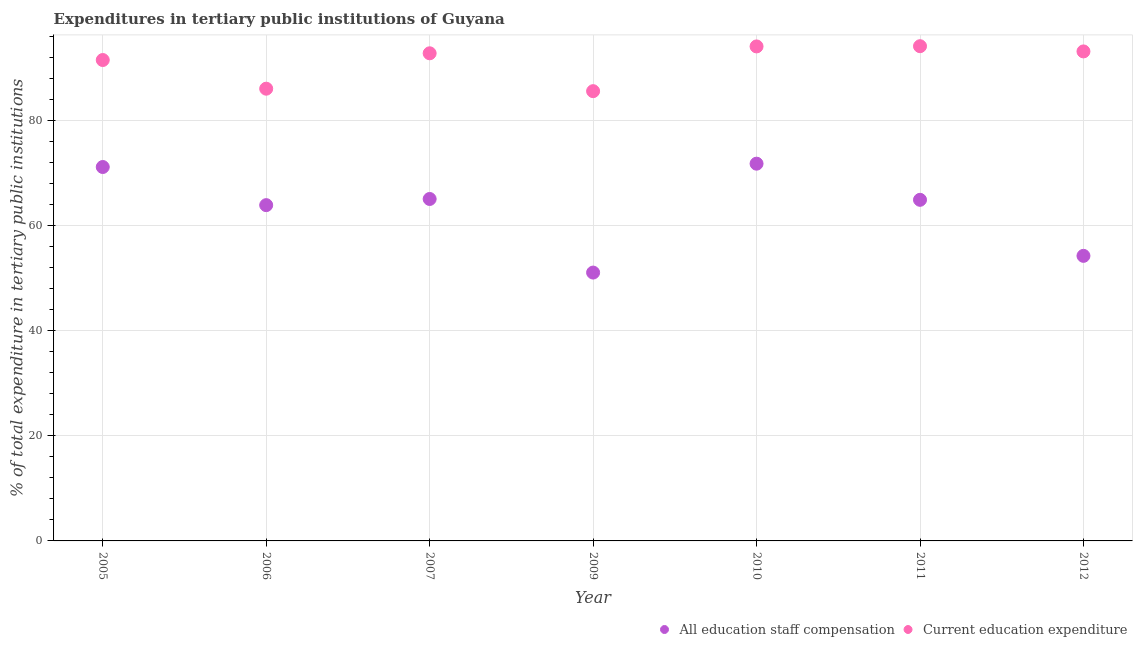How many different coloured dotlines are there?
Offer a very short reply. 2. Is the number of dotlines equal to the number of legend labels?
Provide a succinct answer. Yes. What is the expenditure in education in 2012?
Give a very brief answer. 93.13. Across all years, what is the maximum expenditure in education?
Provide a short and direct response. 94.13. Across all years, what is the minimum expenditure in education?
Provide a succinct answer. 85.57. In which year was the expenditure in staff compensation maximum?
Your response must be concise. 2010. In which year was the expenditure in staff compensation minimum?
Give a very brief answer. 2009. What is the total expenditure in staff compensation in the graph?
Provide a succinct answer. 442.04. What is the difference between the expenditure in staff compensation in 2009 and that in 2012?
Ensure brevity in your answer.  -3.18. What is the difference between the expenditure in staff compensation in 2010 and the expenditure in education in 2006?
Provide a succinct answer. -14.27. What is the average expenditure in staff compensation per year?
Offer a very short reply. 63.15. In the year 2011, what is the difference between the expenditure in staff compensation and expenditure in education?
Offer a terse response. -29.23. In how many years, is the expenditure in education greater than 68 %?
Keep it short and to the point. 7. What is the ratio of the expenditure in education in 2005 to that in 2012?
Your response must be concise. 0.98. Is the expenditure in education in 2007 less than that in 2011?
Your answer should be very brief. Yes. Is the difference between the expenditure in education in 2007 and 2012 greater than the difference between the expenditure in staff compensation in 2007 and 2012?
Provide a short and direct response. No. What is the difference between the highest and the second highest expenditure in staff compensation?
Your response must be concise. 0.63. What is the difference between the highest and the lowest expenditure in staff compensation?
Offer a very short reply. 20.72. In how many years, is the expenditure in education greater than the average expenditure in education taken over all years?
Provide a short and direct response. 5. Does the expenditure in staff compensation monotonically increase over the years?
Make the answer very short. No. Is the expenditure in staff compensation strictly less than the expenditure in education over the years?
Provide a short and direct response. Yes. Does the graph contain any zero values?
Keep it short and to the point. No. Does the graph contain grids?
Give a very brief answer. Yes. How many legend labels are there?
Your response must be concise. 2. What is the title of the graph?
Offer a terse response. Expenditures in tertiary public institutions of Guyana. Does "Enforce a contract" appear as one of the legend labels in the graph?
Your response must be concise. No. What is the label or title of the X-axis?
Make the answer very short. Year. What is the label or title of the Y-axis?
Make the answer very short. % of total expenditure in tertiary public institutions. What is the % of total expenditure in tertiary public institutions of All education staff compensation in 2005?
Make the answer very short. 71.14. What is the % of total expenditure in tertiary public institutions in Current education expenditure in 2005?
Give a very brief answer. 91.49. What is the % of total expenditure in tertiary public institutions in All education staff compensation in 2006?
Provide a short and direct response. 63.88. What is the % of total expenditure in tertiary public institutions in Current education expenditure in 2006?
Provide a succinct answer. 86.04. What is the % of total expenditure in tertiary public institutions in All education staff compensation in 2007?
Your response must be concise. 65.06. What is the % of total expenditure in tertiary public institutions of Current education expenditure in 2007?
Make the answer very short. 92.78. What is the % of total expenditure in tertiary public institutions in All education staff compensation in 2009?
Your answer should be very brief. 51.05. What is the % of total expenditure in tertiary public institutions in Current education expenditure in 2009?
Offer a terse response. 85.57. What is the % of total expenditure in tertiary public institutions of All education staff compensation in 2010?
Your answer should be compact. 71.77. What is the % of total expenditure in tertiary public institutions of Current education expenditure in 2010?
Offer a very short reply. 94.08. What is the % of total expenditure in tertiary public institutions in All education staff compensation in 2011?
Your answer should be compact. 64.9. What is the % of total expenditure in tertiary public institutions of Current education expenditure in 2011?
Ensure brevity in your answer.  94.13. What is the % of total expenditure in tertiary public institutions of All education staff compensation in 2012?
Offer a terse response. 54.24. What is the % of total expenditure in tertiary public institutions in Current education expenditure in 2012?
Provide a short and direct response. 93.13. Across all years, what is the maximum % of total expenditure in tertiary public institutions in All education staff compensation?
Keep it short and to the point. 71.77. Across all years, what is the maximum % of total expenditure in tertiary public institutions in Current education expenditure?
Your answer should be compact. 94.13. Across all years, what is the minimum % of total expenditure in tertiary public institutions in All education staff compensation?
Offer a very short reply. 51.05. Across all years, what is the minimum % of total expenditure in tertiary public institutions in Current education expenditure?
Your answer should be very brief. 85.57. What is the total % of total expenditure in tertiary public institutions in All education staff compensation in the graph?
Give a very brief answer. 442.04. What is the total % of total expenditure in tertiary public institutions in Current education expenditure in the graph?
Make the answer very short. 637.22. What is the difference between the % of total expenditure in tertiary public institutions in All education staff compensation in 2005 and that in 2006?
Give a very brief answer. 7.26. What is the difference between the % of total expenditure in tertiary public institutions in Current education expenditure in 2005 and that in 2006?
Your answer should be very brief. 5.45. What is the difference between the % of total expenditure in tertiary public institutions in All education staff compensation in 2005 and that in 2007?
Ensure brevity in your answer.  6.08. What is the difference between the % of total expenditure in tertiary public institutions in Current education expenditure in 2005 and that in 2007?
Keep it short and to the point. -1.28. What is the difference between the % of total expenditure in tertiary public institutions in All education staff compensation in 2005 and that in 2009?
Your response must be concise. 20.09. What is the difference between the % of total expenditure in tertiary public institutions in Current education expenditure in 2005 and that in 2009?
Offer a terse response. 5.92. What is the difference between the % of total expenditure in tertiary public institutions in All education staff compensation in 2005 and that in 2010?
Your answer should be compact. -0.63. What is the difference between the % of total expenditure in tertiary public institutions in Current education expenditure in 2005 and that in 2010?
Offer a terse response. -2.59. What is the difference between the % of total expenditure in tertiary public institutions of All education staff compensation in 2005 and that in 2011?
Your answer should be compact. 6.24. What is the difference between the % of total expenditure in tertiary public institutions in Current education expenditure in 2005 and that in 2011?
Your answer should be very brief. -2.63. What is the difference between the % of total expenditure in tertiary public institutions in All education staff compensation in 2005 and that in 2012?
Make the answer very short. 16.9. What is the difference between the % of total expenditure in tertiary public institutions in Current education expenditure in 2005 and that in 2012?
Your response must be concise. -1.64. What is the difference between the % of total expenditure in tertiary public institutions in All education staff compensation in 2006 and that in 2007?
Ensure brevity in your answer.  -1.17. What is the difference between the % of total expenditure in tertiary public institutions of Current education expenditure in 2006 and that in 2007?
Your response must be concise. -6.73. What is the difference between the % of total expenditure in tertiary public institutions in All education staff compensation in 2006 and that in 2009?
Your answer should be compact. 12.83. What is the difference between the % of total expenditure in tertiary public institutions in Current education expenditure in 2006 and that in 2009?
Offer a terse response. 0.47. What is the difference between the % of total expenditure in tertiary public institutions in All education staff compensation in 2006 and that in 2010?
Your answer should be compact. -7.89. What is the difference between the % of total expenditure in tertiary public institutions of Current education expenditure in 2006 and that in 2010?
Provide a succinct answer. -8.04. What is the difference between the % of total expenditure in tertiary public institutions in All education staff compensation in 2006 and that in 2011?
Offer a very short reply. -1.01. What is the difference between the % of total expenditure in tertiary public institutions of Current education expenditure in 2006 and that in 2011?
Give a very brief answer. -8.09. What is the difference between the % of total expenditure in tertiary public institutions in All education staff compensation in 2006 and that in 2012?
Provide a succinct answer. 9.65. What is the difference between the % of total expenditure in tertiary public institutions in Current education expenditure in 2006 and that in 2012?
Your response must be concise. -7.09. What is the difference between the % of total expenditure in tertiary public institutions of All education staff compensation in 2007 and that in 2009?
Keep it short and to the point. 14. What is the difference between the % of total expenditure in tertiary public institutions of Current education expenditure in 2007 and that in 2009?
Your answer should be very brief. 7.21. What is the difference between the % of total expenditure in tertiary public institutions of All education staff compensation in 2007 and that in 2010?
Ensure brevity in your answer.  -6.72. What is the difference between the % of total expenditure in tertiary public institutions in Current education expenditure in 2007 and that in 2010?
Make the answer very short. -1.31. What is the difference between the % of total expenditure in tertiary public institutions in All education staff compensation in 2007 and that in 2011?
Give a very brief answer. 0.16. What is the difference between the % of total expenditure in tertiary public institutions of Current education expenditure in 2007 and that in 2011?
Make the answer very short. -1.35. What is the difference between the % of total expenditure in tertiary public institutions in All education staff compensation in 2007 and that in 2012?
Make the answer very short. 10.82. What is the difference between the % of total expenditure in tertiary public institutions in Current education expenditure in 2007 and that in 2012?
Keep it short and to the point. -0.36. What is the difference between the % of total expenditure in tertiary public institutions in All education staff compensation in 2009 and that in 2010?
Give a very brief answer. -20.72. What is the difference between the % of total expenditure in tertiary public institutions of Current education expenditure in 2009 and that in 2010?
Offer a terse response. -8.51. What is the difference between the % of total expenditure in tertiary public institutions in All education staff compensation in 2009 and that in 2011?
Provide a succinct answer. -13.84. What is the difference between the % of total expenditure in tertiary public institutions in Current education expenditure in 2009 and that in 2011?
Ensure brevity in your answer.  -8.56. What is the difference between the % of total expenditure in tertiary public institutions of All education staff compensation in 2009 and that in 2012?
Provide a succinct answer. -3.18. What is the difference between the % of total expenditure in tertiary public institutions of Current education expenditure in 2009 and that in 2012?
Provide a succinct answer. -7.56. What is the difference between the % of total expenditure in tertiary public institutions in All education staff compensation in 2010 and that in 2011?
Keep it short and to the point. 6.88. What is the difference between the % of total expenditure in tertiary public institutions in Current education expenditure in 2010 and that in 2011?
Offer a very short reply. -0.04. What is the difference between the % of total expenditure in tertiary public institutions of All education staff compensation in 2010 and that in 2012?
Keep it short and to the point. 17.54. What is the difference between the % of total expenditure in tertiary public institutions in Current education expenditure in 2010 and that in 2012?
Ensure brevity in your answer.  0.95. What is the difference between the % of total expenditure in tertiary public institutions in All education staff compensation in 2011 and that in 2012?
Keep it short and to the point. 10.66. What is the difference between the % of total expenditure in tertiary public institutions in All education staff compensation in 2005 and the % of total expenditure in tertiary public institutions in Current education expenditure in 2006?
Your response must be concise. -14.9. What is the difference between the % of total expenditure in tertiary public institutions of All education staff compensation in 2005 and the % of total expenditure in tertiary public institutions of Current education expenditure in 2007?
Your answer should be compact. -21.64. What is the difference between the % of total expenditure in tertiary public institutions of All education staff compensation in 2005 and the % of total expenditure in tertiary public institutions of Current education expenditure in 2009?
Your answer should be very brief. -14.43. What is the difference between the % of total expenditure in tertiary public institutions in All education staff compensation in 2005 and the % of total expenditure in tertiary public institutions in Current education expenditure in 2010?
Offer a terse response. -22.94. What is the difference between the % of total expenditure in tertiary public institutions of All education staff compensation in 2005 and the % of total expenditure in tertiary public institutions of Current education expenditure in 2011?
Provide a succinct answer. -22.99. What is the difference between the % of total expenditure in tertiary public institutions in All education staff compensation in 2005 and the % of total expenditure in tertiary public institutions in Current education expenditure in 2012?
Your answer should be very brief. -21.99. What is the difference between the % of total expenditure in tertiary public institutions of All education staff compensation in 2006 and the % of total expenditure in tertiary public institutions of Current education expenditure in 2007?
Offer a very short reply. -28.89. What is the difference between the % of total expenditure in tertiary public institutions in All education staff compensation in 2006 and the % of total expenditure in tertiary public institutions in Current education expenditure in 2009?
Offer a terse response. -21.69. What is the difference between the % of total expenditure in tertiary public institutions of All education staff compensation in 2006 and the % of total expenditure in tertiary public institutions of Current education expenditure in 2010?
Offer a terse response. -30.2. What is the difference between the % of total expenditure in tertiary public institutions in All education staff compensation in 2006 and the % of total expenditure in tertiary public institutions in Current education expenditure in 2011?
Your answer should be very brief. -30.24. What is the difference between the % of total expenditure in tertiary public institutions in All education staff compensation in 2006 and the % of total expenditure in tertiary public institutions in Current education expenditure in 2012?
Offer a terse response. -29.25. What is the difference between the % of total expenditure in tertiary public institutions in All education staff compensation in 2007 and the % of total expenditure in tertiary public institutions in Current education expenditure in 2009?
Your response must be concise. -20.51. What is the difference between the % of total expenditure in tertiary public institutions of All education staff compensation in 2007 and the % of total expenditure in tertiary public institutions of Current education expenditure in 2010?
Provide a short and direct response. -29.02. What is the difference between the % of total expenditure in tertiary public institutions of All education staff compensation in 2007 and the % of total expenditure in tertiary public institutions of Current education expenditure in 2011?
Provide a short and direct response. -29.07. What is the difference between the % of total expenditure in tertiary public institutions of All education staff compensation in 2007 and the % of total expenditure in tertiary public institutions of Current education expenditure in 2012?
Ensure brevity in your answer.  -28.07. What is the difference between the % of total expenditure in tertiary public institutions of All education staff compensation in 2009 and the % of total expenditure in tertiary public institutions of Current education expenditure in 2010?
Your response must be concise. -43.03. What is the difference between the % of total expenditure in tertiary public institutions of All education staff compensation in 2009 and the % of total expenditure in tertiary public institutions of Current education expenditure in 2011?
Ensure brevity in your answer.  -43.07. What is the difference between the % of total expenditure in tertiary public institutions of All education staff compensation in 2009 and the % of total expenditure in tertiary public institutions of Current education expenditure in 2012?
Your answer should be compact. -42.08. What is the difference between the % of total expenditure in tertiary public institutions in All education staff compensation in 2010 and the % of total expenditure in tertiary public institutions in Current education expenditure in 2011?
Provide a short and direct response. -22.35. What is the difference between the % of total expenditure in tertiary public institutions of All education staff compensation in 2010 and the % of total expenditure in tertiary public institutions of Current education expenditure in 2012?
Your answer should be very brief. -21.36. What is the difference between the % of total expenditure in tertiary public institutions of All education staff compensation in 2011 and the % of total expenditure in tertiary public institutions of Current education expenditure in 2012?
Ensure brevity in your answer.  -28.23. What is the average % of total expenditure in tertiary public institutions in All education staff compensation per year?
Provide a succinct answer. 63.15. What is the average % of total expenditure in tertiary public institutions in Current education expenditure per year?
Make the answer very short. 91.03. In the year 2005, what is the difference between the % of total expenditure in tertiary public institutions in All education staff compensation and % of total expenditure in tertiary public institutions in Current education expenditure?
Your response must be concise. -20.35. In the year 2006, what is the difference between the % of total expenditure in tertiary public institutions of All education staff compensation and % of total expenditure in tertiary public institutions of Current education expenditure?
Give a very brief answer. -22.16. In the year 2007, what is the difference between the % of total expenditure in tertiary public institutions in All education staff compensation and % of total expenditure in tertiary public institutions in Current education expenditure?
Your answer should be compact. -27.72. In the year 2009, what is the difference between the % of total expenditure in tertiary public institutions in All education staff compensation and % of total expenditure in tertiary public institutions in Current education expenditure?
Your response must be concise. -34.52. In the year 2010, what is the difference between the % of total expenditure in tertiary public institutions of All education staff compensation and % of total expenditure in tertiary public institutions of Current education expenditure?
Keep it short and to the point. -22.31. In the year 2011, what is the difference between the % of total expenditure in tertiary public institutions of All education staff compensation and % of total expenditure in tertiary public institutions of Current education expenditure?
Ensure brevity in your answer.  -29.23. In the year 2012, what is the difference between the % of total expenditure in tertiary public institutions of All education staff compensation and % of total expenditure in tertiary public institutions of Current education expenditure?
Ensure brevity in your answer.  -38.9. What is the ratio of the % of total expenditure in tertiary public institutions in All education staff compensation in 2005 to that in 2006?
Provide a short and direct response. 1.11. What is the ratio of the % of total expenditure in tertiary public institutions of Current education expenditure in 2005 to that in 2006?
Make the answer very short. 1.06. What is the ratio of the % of total expenditure in tertiary public institutions in All education staff compensation in 2005 to that in 2007?
Provide a succinct answer. 1.09. What is the ratio of the % of total expenditure in tertiary public institutions in Current education expenditure in 2005 to that in 2007?
Your response must be concise. 0.99. What is the ratio of the % of total expenditure in tertiary public institutions of All education staff compensation in 2005 to that in 2009?
Offer a very short reply. 1.39. What is the ratio of the % of total expenditure in tertiary public institutions in Current education expenditure in 2005 to that in 2009?
Ensure brevity in your answer.  1.07. What is the ratio of the % of total expenditure in tertiary public institutions in Current education expenditure in 2005 to that in 2010?
Offer a very short reply. 0.97. What is the ratio of the % of total expenditure in tertiary public institutions of All education staff compensation in 2005 to that in 2011?
Offer a very short reply. 1.1. What is the ratio of the % of total expenditure in tertiary public institutions of All education staff compensation in 2005 to that in 2012?
Your answer should be compact. 1.31. What is the ratio of the % of total expenditure in tertiary public institutions of Current education expenditure in 2005 to that in 2012?
Your answer should be compact. 0.98. What is the ratio of the % of total expenditure in tertiary public institutions of All education staff compensation in 2006 to that in 2007?
Your answer should be compact. 0.98. What is the ratio of the % of total expenditure in tertiary public institutions of Current education expenditure in 2006 to that in 2007?
Give a very brief answer. 0.93. What is the ratio of the % of total expenditure in tertiary public institutions in All education staff compensation in 2006 to that in 2009?
Offer a very short reply. 1.25. What is the ratio of the % of total expenditure in tertiary public institutions of Current education expenditure in 2006 to that in 2009?
Give a very brief answer. 1.01. What is the ratio of the % of total expenditure in tertiary public institutions in All education staff compensation in 2006 to that in 2010?
Your response must be concise. 0.89. What is the ratio of the % of total expenditure in tertiary public institutions of Current education expenditure in 2006 to that in 2010?
Make the answer very short. 0.91. What is the ratio of the % of total expenditure in tertiary public institutions in All education staff compensation in 2006 to that in 2011?
Give a very brief answer. 0.98. What is the ratio of the % of total expenditure in tertiary public institutions of Current education expenditure in 2006 to that in 2011?
Offer a terse response. 0.91. What is the ratio of the % of total expenditure in tertiary public institutions in All education staff compensation in 2006 to that in 2012?
Offer a very short reply. 1.18. What is the ratio of the % of total expenditure in tertiary public institutions of Current education expenditure in 2006 to that in 2012?
Offer a terse response. 0.92. What is the ratio of the % of total expenditure in tertiary public institutions in All education staff compensation in 2007 to that in 2009?
Offer a very short reply. 1.27. What is the ratio of the % of total expenditure in tertiary public institutions in Current education expenditure in 2007 to that in 2009?
Provide a short and direct response. 1.08. What is the ratio of the % of total expenditure in tertiary public institutions of All education staff compensation in 2007 to that in 2010?
Provide a short and direct response. 0.91. What is the ratio of the % of total expenditure in tertiary public institutions in Current education expenditure in 2007 to that in 2010?
Provide a succinct answer. 0.99. What is the ratio of the % of total expenditure in tertiary public institutions of All education staff compensation in 2007 to that in 2011?
Ensure brevity in your answer.  1. What is the ratio of the % of total expenditure in tertiary public institutions in Current education expenditure in 2007 to that in 2011?
Ensure brevity in your answer.  0.99. What is the ratio of the % of total expenditure in tertiary public institutions in All education staff compensation in 2007 to that in 2012?
Make the answer very short. 1.2. What is the ratio of the % of total expenditure in tertiary public institutions of All education staff compensation in 2009 to that in 2010?
Your answer should be compact. 0.71. What is the ratio of the % of total expenditure in tertiary public institutions of Current education expenditure in 2009 to that in 2010?
Provide a short and direct response. 0.91. What is the ratio of the % of total expenditure in tertiary public institutions in All education staff compensation in 2009 to that in 2011?
Provide a short and direct response. 0.79. What is the ratio of the % of total expenditure in tertiary public institutions in All education staff compensation in 2009 to that in 2012?
Give a very brief answer. 0.94. What is the ratio of the % of total expenditure in tertiary public institutions of Current education expenditure in 2009 to that in 2012?
Give a very brief answer. 0.92. What is the ratio of the % of total expenditure in tertiary public institutions of All education staff compensation in 2010 to that in 2011?
Provide a succinct answer. 1.11. What is the ratio of the % of total expenditure in tertiary public institutions in All education staff compensation in 2010 to that in 2012?
Ensure brevity in your answer.  1.32. What is the ratio of the % of total expenditure in tertiary public institutions in Current education expenditure in 2010 to that in 2012?
Your response must be concise. 1.01. What is the ratio of the % of total expenditure in tertiary public institutions in All education staff compensation in 2011 to that in 2012?
Your answer should be very brief. 1.2. What is the ratio of the % of total expenditure in tertiary public institutions in Current education expenditure in 2011 to that in 2012?
Keep it short and to the point. 1.01. What is the difference between the highest and the second highest % of total expenditure in tertiary public institutions in All education staff compensation?
Give a very brief answer. 0.63. What is the difference between the highest and the second highest % of total expenditure in tertiary public institutions of Current education expenditure?
Make the answer very short. 0.04. What is the difference between the highest and the lowest % of total expenditure in tertiary public institutions of All education staff compensation?
Your response must be concise. 20.72. What is the difference between the highest and the lowest % of total expenditure in tertiary public institutions of Current education expenditure?
Your response must be concise. 8.56. 